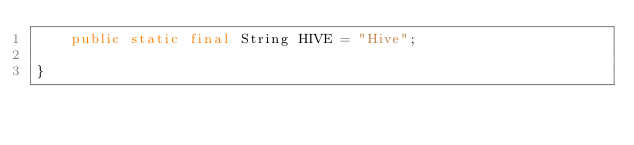<code> <loc_0><loc_0><loc_500><loc_500><_Java_>    public static final String HIVE = "Hive";

}
</code> 